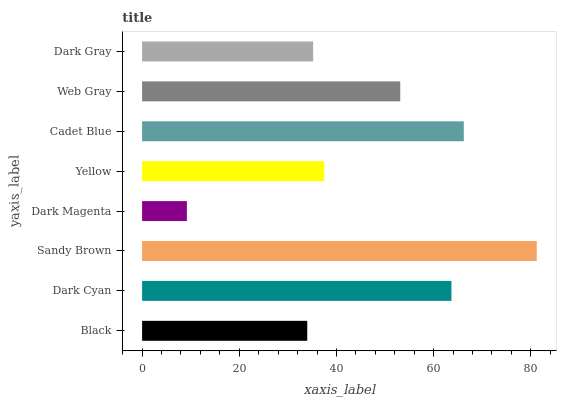Is Dark Magenta the minimum?
Answer yes or no. Yes. Is Sandy Brown the maximum?
Answer yes or no. Yes. Is Dark Cyan the minimum?
Answer yes or no. No. Is Dark Cyan the maximum?
Answer yes or no. No. Is Dark Cyan greater than Black?
Answer yes or no. Yes. Is Black less than Dark Cyan?
Answer yes or no. Yes. Is Black greater than Dark Cyan?
Answer yes or no. No. Is Dark Cyan less than Black?
Answer yes or no. No. Is Web Gray the high median?
Answer yes or no. Yes. Is Yellow the low median?
Answer yes or no. Yes. Is Sandy Brown the high median?
Answer yes or no. No. Is Dark Cyan the low median?
Answer yes or no. No. 